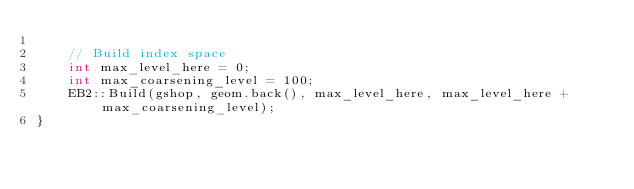<code> <loc_0><loc_0><loc_500><loc_500><_C++_>
    // Build index space
    int max_level_here = 0;
    int max_coarsening_level = 100;
    EB2::Build(gshop, geom.back(), max_level_here, max_level_here + max_coarsening_level);
}
</code> 